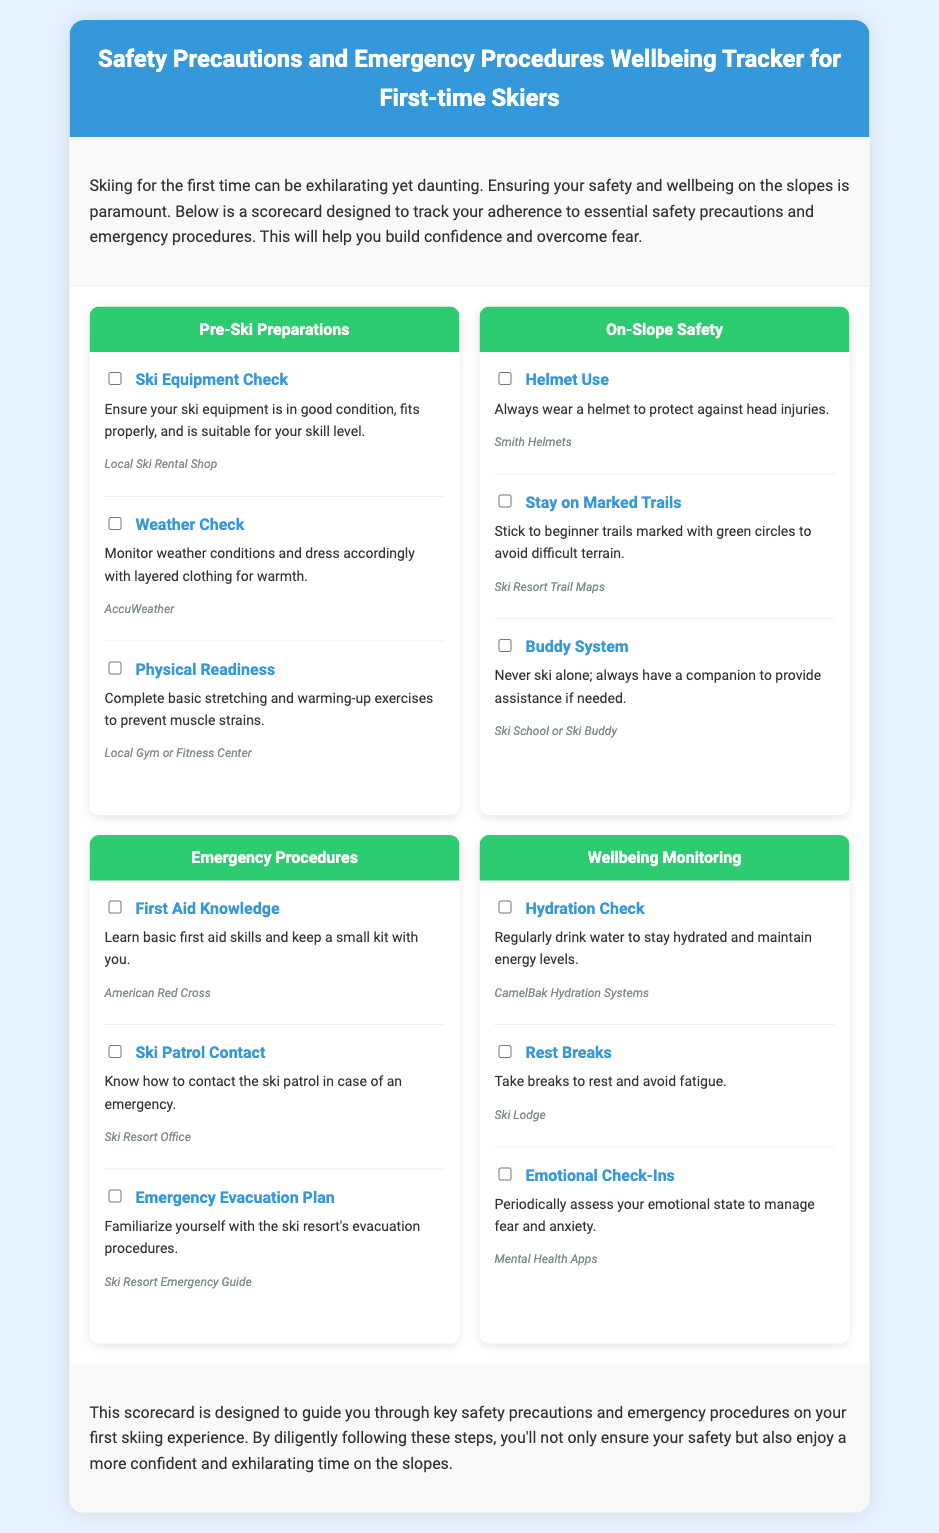what is the title of the document? The title is provided in the header section of the document.
Answer: Safety Precautions and Emergency Procedures Wellbeing Tracker for First-time Skiers how many categories are in the scorecard? The scorecard includes four distinct categories as detailed in the document.
Answer: four what should you wear to ensure safety? This information can be found in the "On-Slope Safety" category, specifically related to head protection.
Answer: helmet which organization is mentioned for first aid knowledge? The document provides suggestions for organizations that offer first aid education.
Answer: American Red Cross what is the purpose of the "Buddy System"? This item addresses the importance of having a companion while skiing for safety reasons.
Answer: provide assistance how often should you check your emotional state? The emphasis is on periodically assessing emotional wellbeing while skiing.
Answer: periodically what is the recommended action to take when fatigued? The document advises regular breaks to maintain energy while skiing.
Answer: take breaks where can you find the ski patrol contact information? This information is specified in the "Emergency Procedures" category.
Answer: Ski Resort Office what are two items included in the "Wellbeing Monitoring" category? The document outlines various elements to maintain wellbeing while skiing.
Answer: Hydration Check, Rest Breaks 